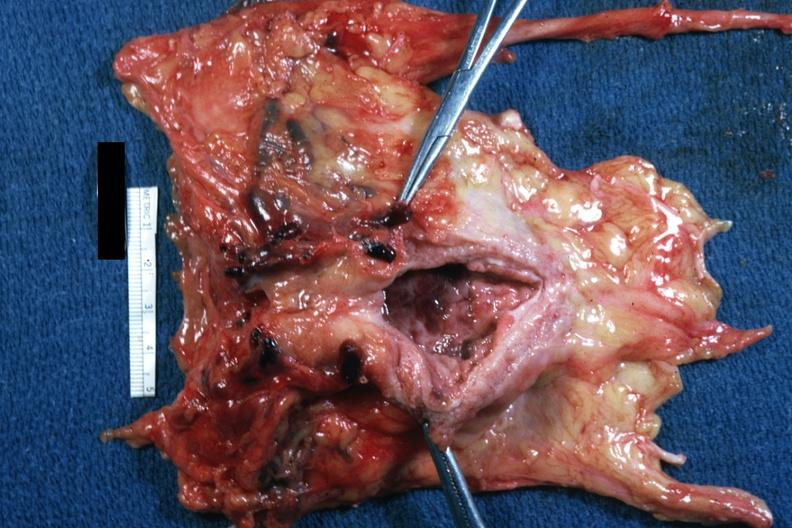what is present?
Answer the question using a single word or phrase. Periprostatic vein thrombi 